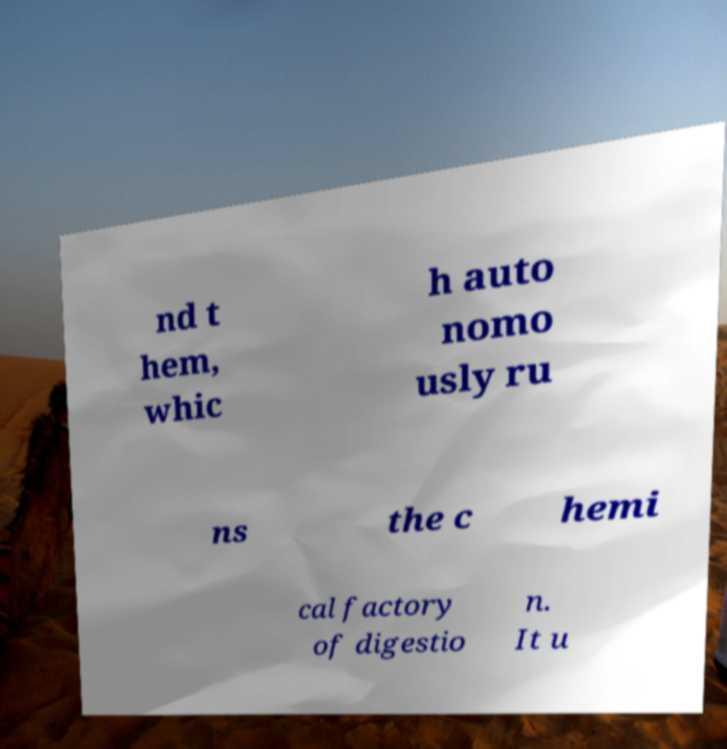For documentation purposes, I need the text within this image transcribed. Could you provide that? nd t hem, whic h auto nomo usly ru ns the c hemi cal factory of digestio n. It u 